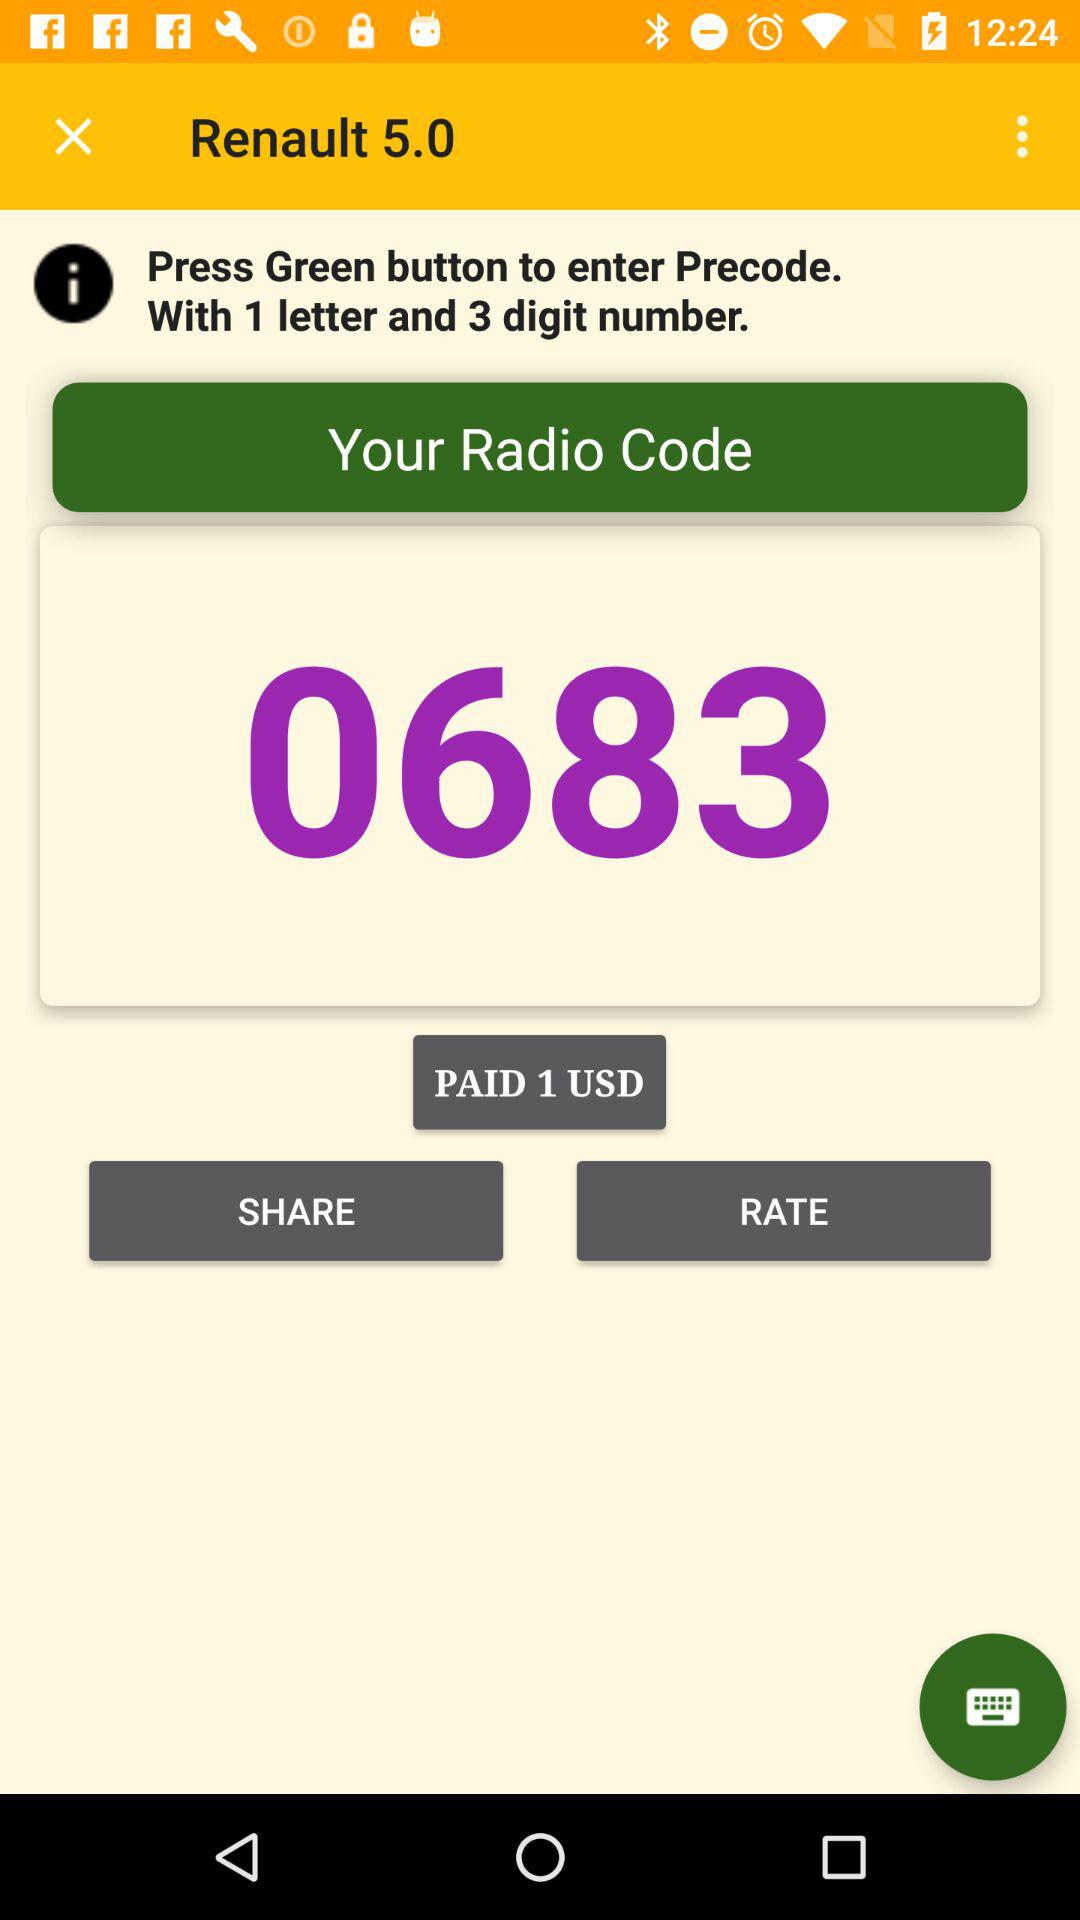How much did I pay for the radio code?
Answer the question using a single word or phrase. 1 USD 